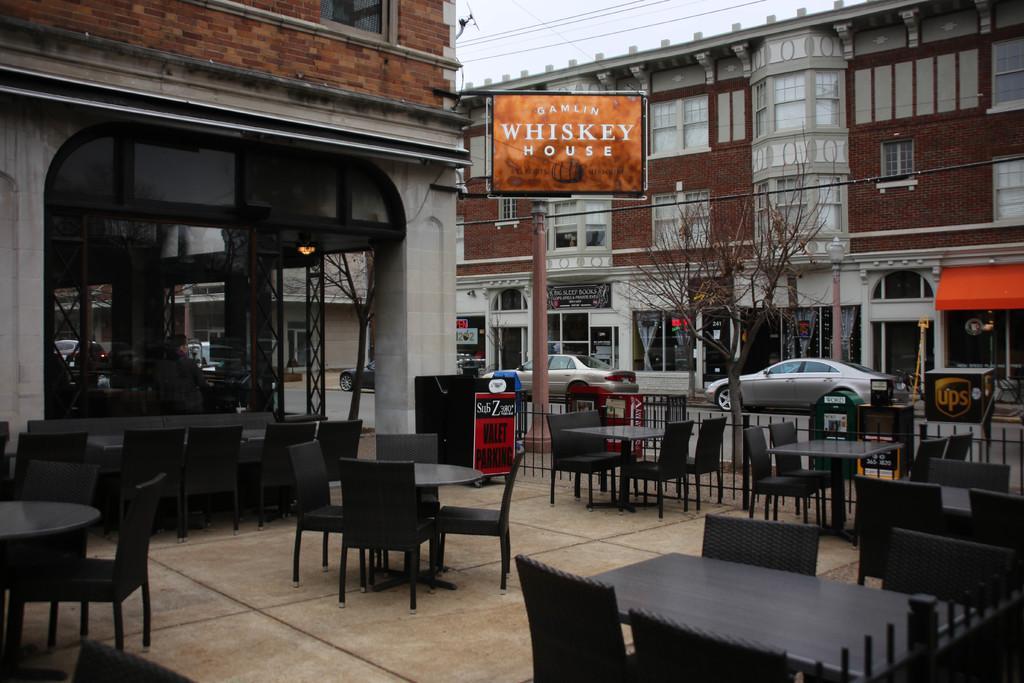In one or two sentences, can you explain what this image depicts? In this picture we can see the outside view of a city. These are the chairs and there are tables. Here we can see two cars on the road. This is building and there is a board. And this is sky. 